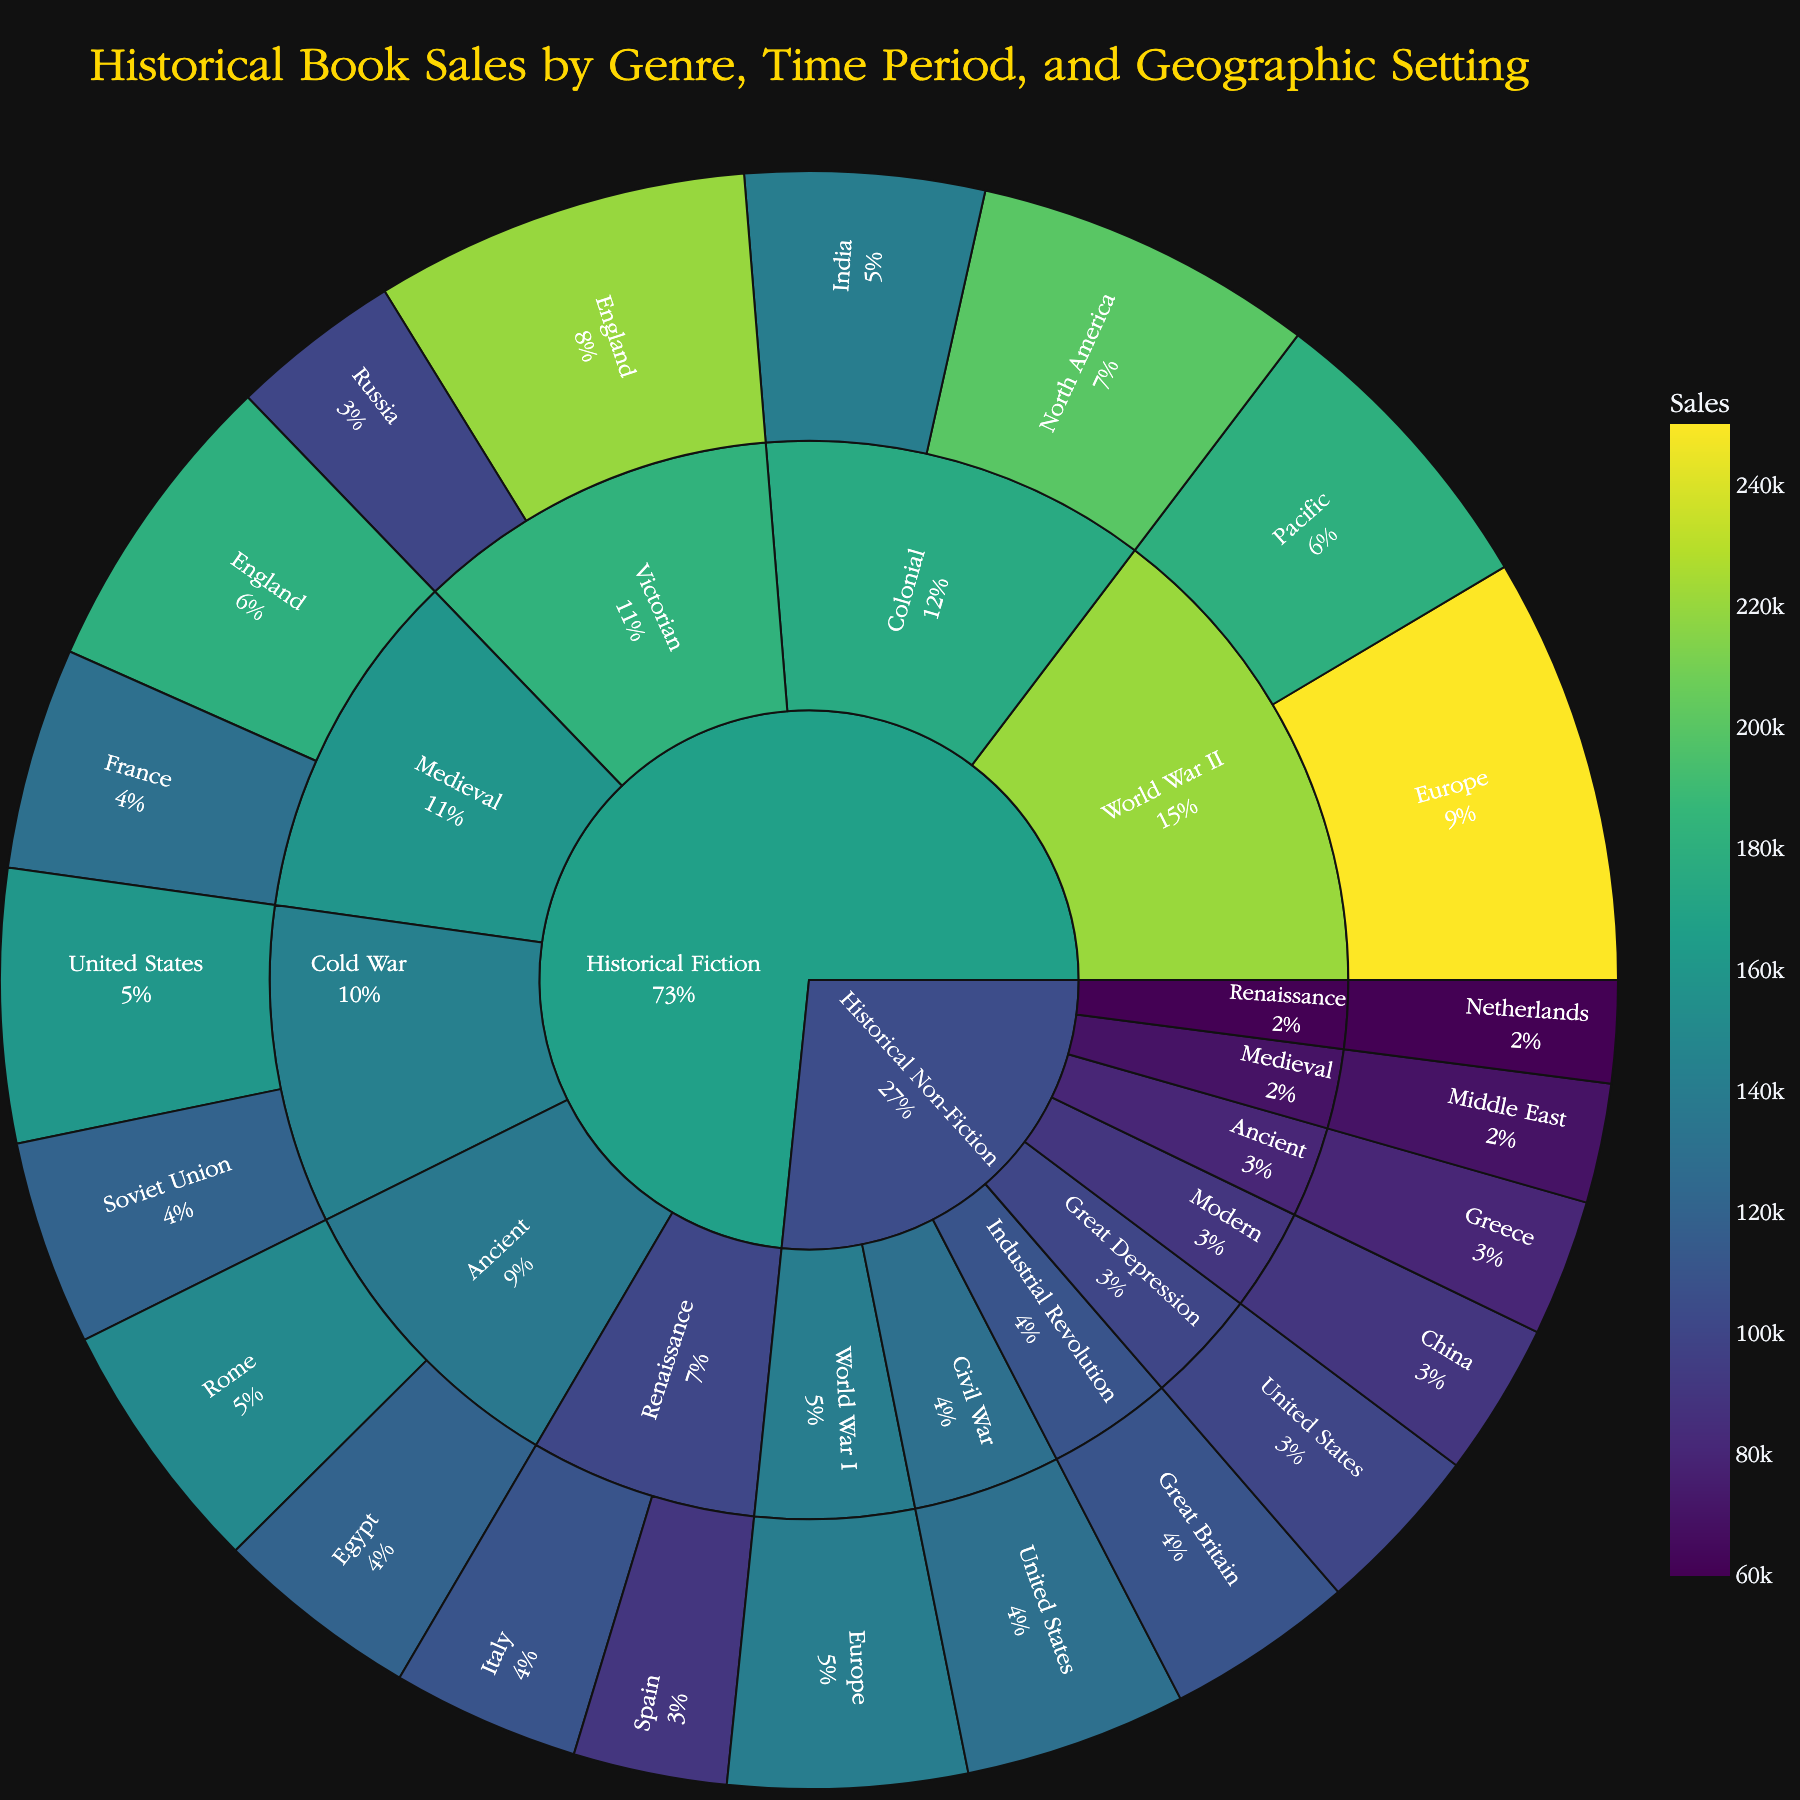What's the title of the plot? The title of the plot is positioned at the top and usually provides a summary of the plotted data. It's designed to give an immediate understanding of what the plot represents.
Answer: Historical Book Sales by Genre, Time Period, and Geographic Setting Which genre has the highest total sales? To determine the genre with the highest total sales, look at the primary segments of the sunburst plot and compare their overall sizes. The genre with the largest area will have the highest total sales.
Answer: Historical Fiction How many geographic settings are represented in the Medieval time period for Historical Fiction? Within the Historical Fiction genre, identify the segment labeled 'Medieval' and count the number of geographic settings branching out from it.
Answer: 2 (England and France) What is the sales difference between Historical Fiction set in Ancient Rome and Ancient Egypt? Locate the segments representing Ancient Rome and Ancient Egypt under the Ancient time period in the Historical Fiction genre, note their sales values, and calculate the difference between these values.
Answer: 30,000 Which time period in Historical Fiction has the highest sales? Look at the segments of the time periods within the Historical Fiction genre and compare the total areas (or values). The time period with the largest segment represents the highest sales.
Answer: World War II Compare the sales for books set in Europe during World War II between Historical Fiction and Historical Non-Fiction. First, identify the sales for World War II in Europe under both Historical Fiction and Historical Non-Fiction genres, then compare these values directly.
Answer: Historical Fiction is 250,000; Historical Non-Fiction is not applicable What percentage of the total sales does Victorian Historical Fiction in England represent? Identify the sales for Victorian Historical Fiction in England and sum the total sales of all segments. Divide the Victorian England sales by the total sales and multiply by 100 to get the percentage.
Answer: (220,000 / Total Sales) * 100 Which geographic setting has the lowest sales in the Cold War time period? In the Cold War time period, locate the geographic settings under both genres and compare their sales to find the smallest value.
Answer: Soviet Union Is there a geographic setting that appears in more than one time period within the same genre? Check each time period within a specific genre and see if any geographic setting is repeated across multiple time periods.
Answer: No What are the sales for Historical Non-Fiction books set in the Modern time period? Locate the segment labeled Modern under Historical Non-Fiction and note the sales figure displayed.
Answer: 90,000 